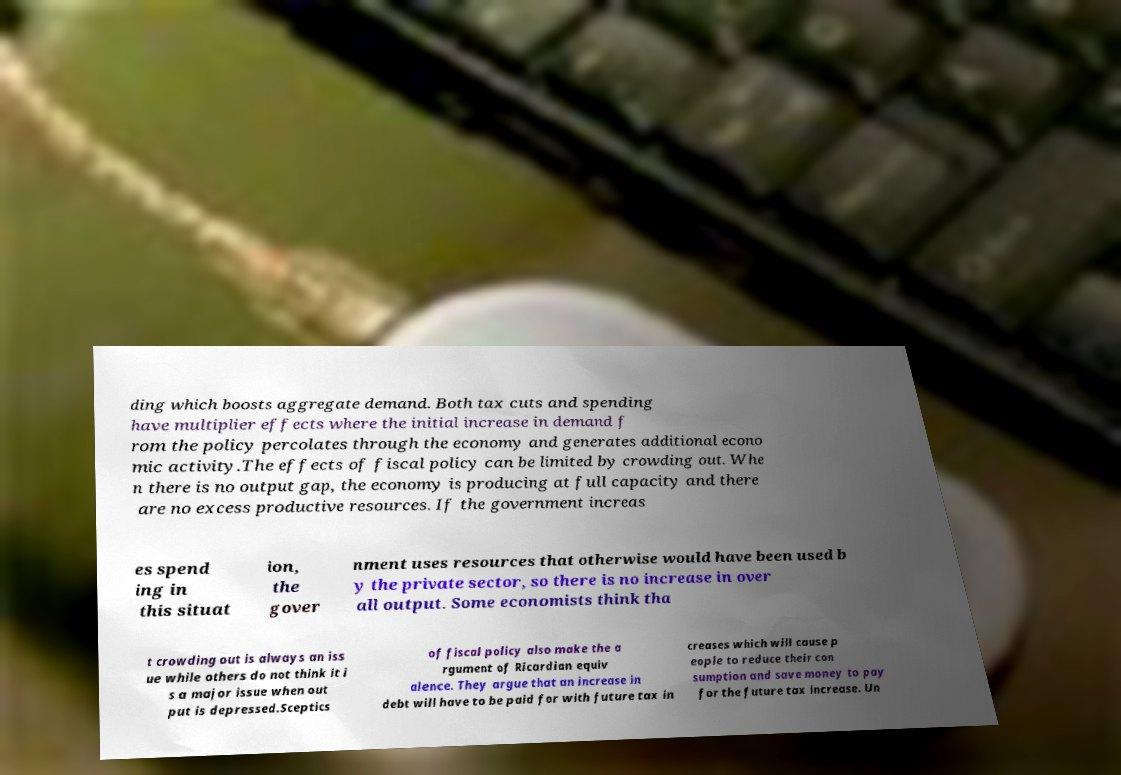There's text embedded in this image that I need extracted. Can you transcribe it verbatim? ding which boosts aggregate demand. Both tax cuts and spending have multiplier effects where the initial increase in demand f rom the policy percolates through the economy and generates additional econo mic activity.The effects of fiscal policy can be limited by crowding out. Whe n there is no output gap, the economy is producing at full capacity and there are no excess productive resources. If the government increas es spend ing in this situat ion, the gover nment uses resources that otherwise would have been used b y the private sector, so there is no increase in over all output. Some economists think tha t crowding out is always an iss ue while others do not think it i s a major issue when out put is depressed.Sceptics of fiscal policy also make the a rgument of Ricardian equiv alence. They argue that an increase in debt will have to be paid for with future tax in creases which will cause p eople to reduce their con sumption and save money to pay for the future tax increase. Un 